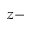<formula> <loc_0><loc_0><loc_500><loc_500>z -</formula> 